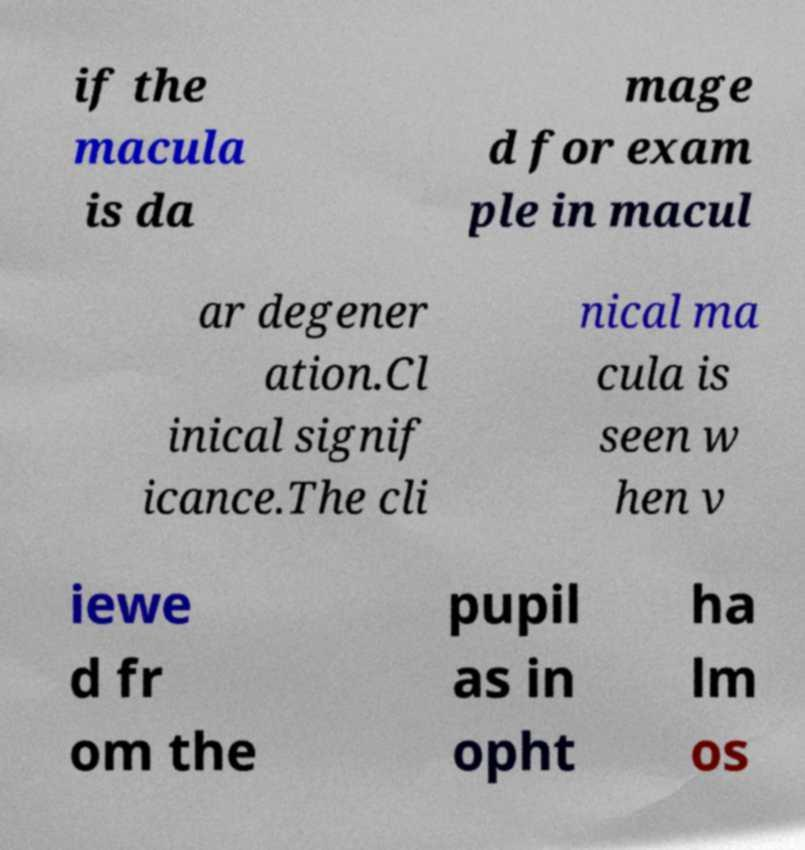For documentation purposes, I need the text within this image transcribed. Could you provide that? if the macula is da mage d for exam ple in macul ar degener ation.Cl inical signif icance.The cli nical ma cula is seen w hen v iewe d fr om the pupil as in opht ha lm os 